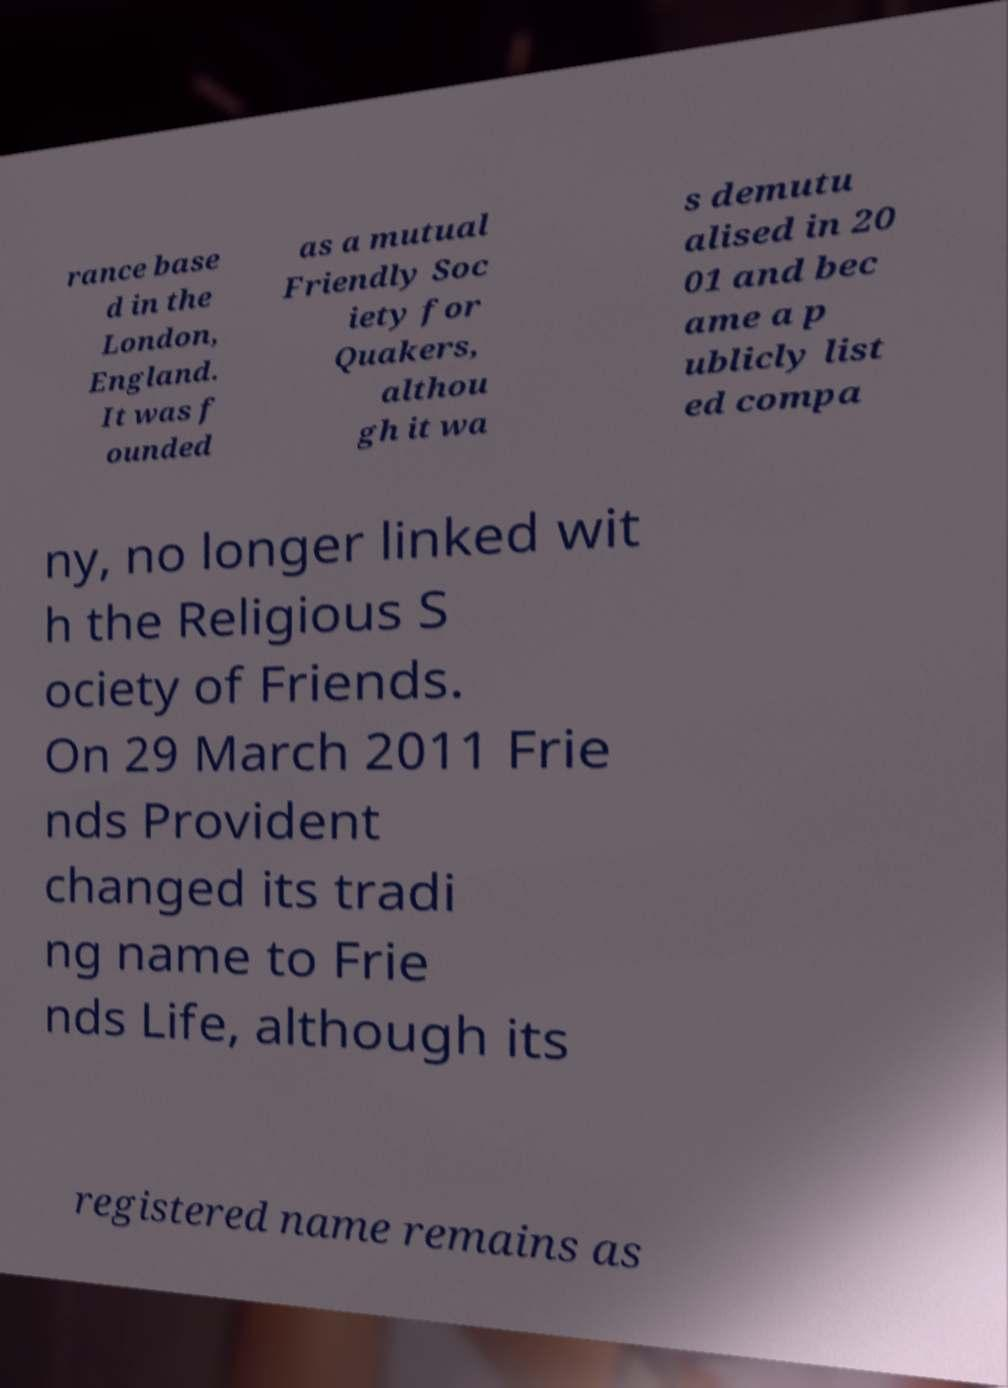Please read and relay the text visible in this image. What does it say? rance base d in the London, England. It was f ounded as a mutual Friendly Soc iety for Quakers, althou gh it wa s demutu alised in 20 01 and bec ame a p ublicly list ed compa ny, no longer linked wit h the Religious S ociety of Friends. On 29 March 2011 Frie nds Provident changed its tradi ng name to Frie nds Life, although its registered name remains as 